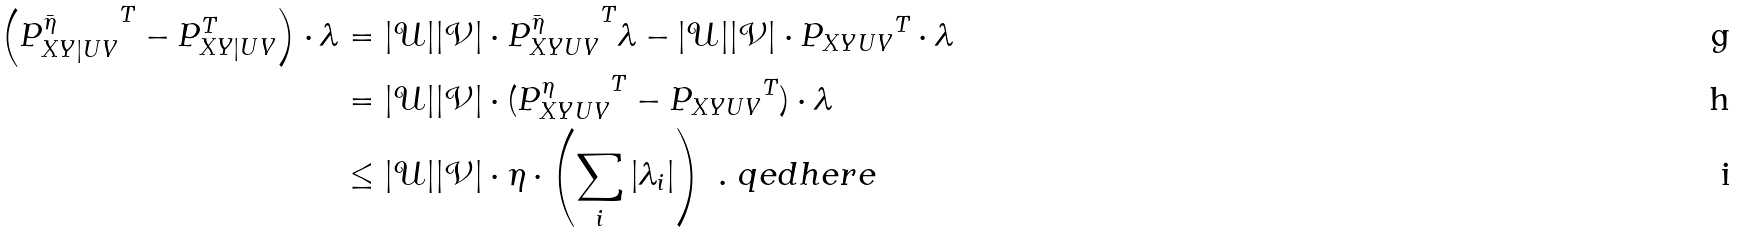<formula> <loc_0><loc_0><loc_500><loc_500>\left ( { P ^ { \bar { \eta } } _ { X Y | U V } } ^ { T } - P _ { X Y | U V } ^ { T } \right ) \cdot \lambda & = | \mathcal { U } | | \mathcal { V } | \cdot { P ^ { \bar { \eta } } _ { X Y U V } } ^ { T } \lambda - | \mathcal { U } | | \mathcal { V } | \cdot { P _ { X Y U V } } ^ { T } \cdot \lambda \\ & = | \mathcal { U } | | \mathcal { V } | \cdot ( { P ^ { \eta } _ { X Y U V } } ^ { T } - { P _ { X Y U V } } ^ { T } ) \cdot \lambda \\ & \leq | \mathcal { U } | | \mathcal { V } | \cdot \eta \cdot \left ( \sum _ { i } | \lambda _ { i } | \right ) \ . \ q e d h e r e</formula> 